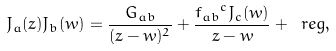Convert formula to latex. <formula><loc_0><loc_0><loc_500><loc_500>J _ { a } ( z ) J _ { b } ( w ) = \frac { G _ { a b } } { ( z - w ) ^ { 2 } } + \frac { { f _ { a b } } ^ { c } J _ { c } ( w ) } { z - w } + \ r e g ,</formula> 